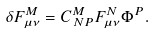<formula> <loc_0><loc_0><loc_500><loc_500>\delta F ^ { M } _ { \mu \nu } = C ^ { M } _ { \, N P } F ^ { N } _ { \mu \nu } \Phi ^ { P } .</formula> 